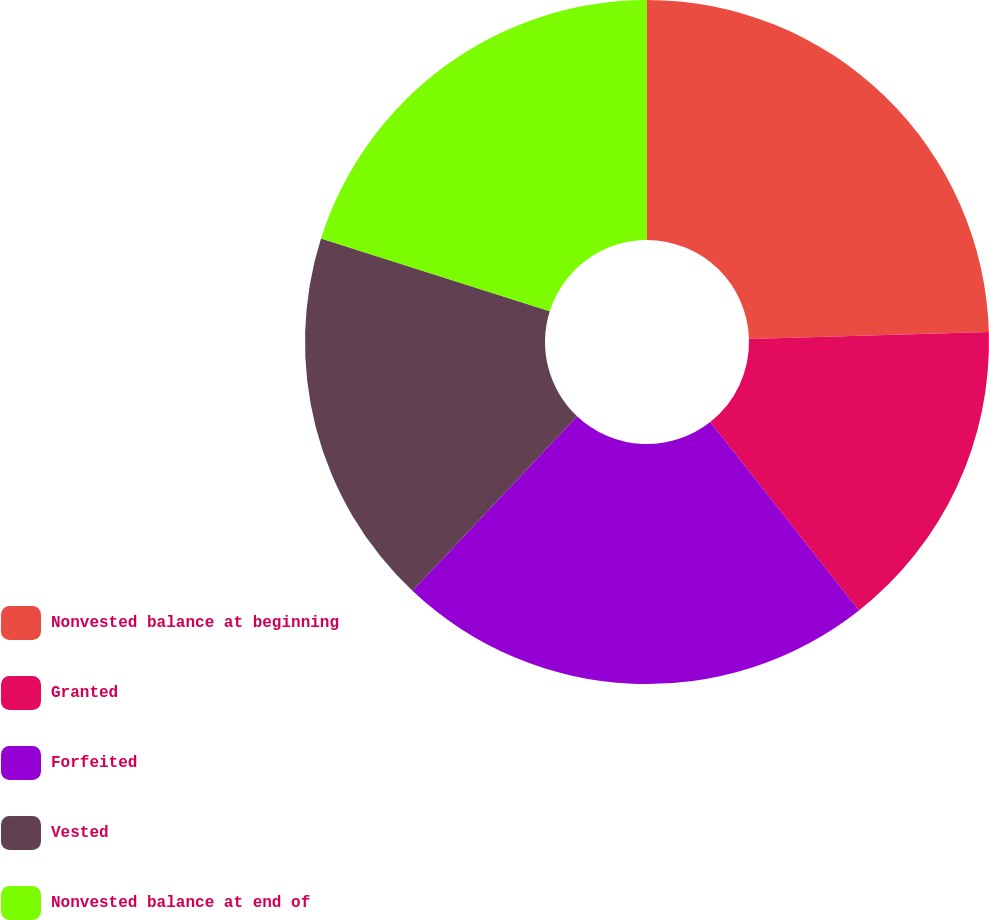Convert chart. <chart><loc_0><loc_0><loc_500><loc_500><pie_chart><fcel>Nonvested balance at beginning<fcel>Granted<fcel>Forfeited<fcel>Vested<fcel>Nonvested balance at end of<nl><fcel>24.54%<fcel>14.82%<fcel>22.67%<fcel>17.86%<fcel>20.11%<nl></chart> 